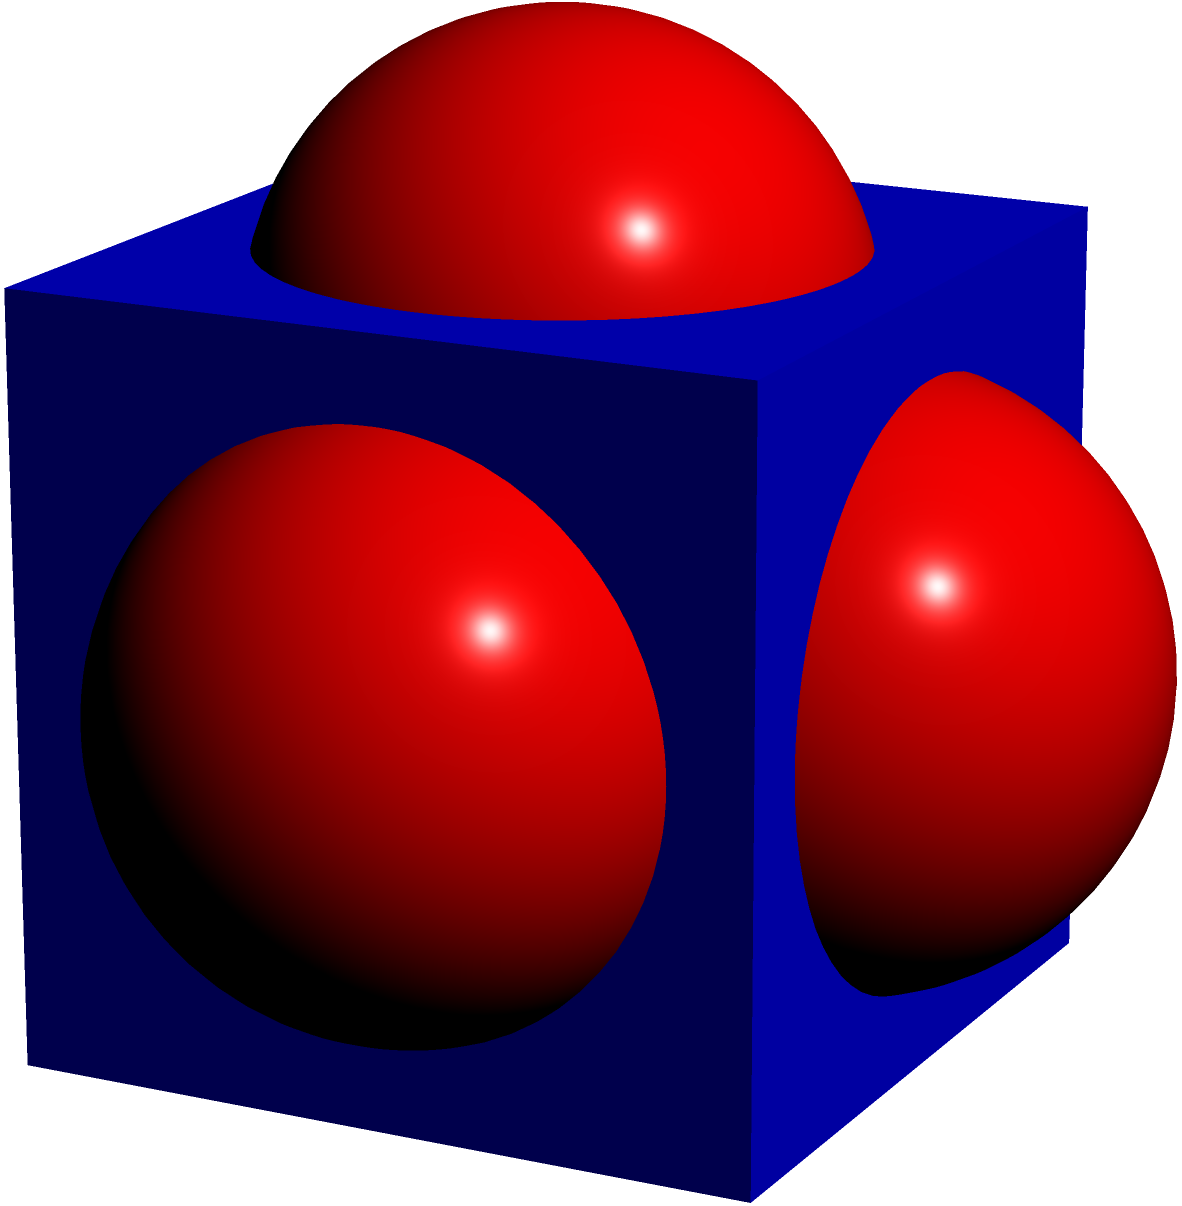As a fruit packer in your new job, you're tasked with efficiently packing spherical fruits into cubic crates. If the length of each side of the cubic crate is 10 inches and the diameter of each spherical fruit is 4 inches, how many fruits can you fit into one crate? To solve this problem, we'll follow these steps:

1) First, we need to determine how many fruits can fit along each dimension of the crate:
   - Length of crate side: 10 inches
   - Diameter of fruit: 4 inches
   - Number of fruits per side = $\lfloor \frac{10}{4} \rfloor = 2$ (we use the floor function as we can't have partial fruits)

2) Since the crate is cubic, this number applies to all three dimensions (length, width, height).

3) The total number of fruits that can fit is the product of the number of fruits in each dimension:
   $2 \times 2 \times 2 = 8$

4) However, this calculation assumes perfect packing, which isn't always possible with spheres. In reality, there might be some small spaces between the fruits, but for this idealized scenario, we'll assume perfect packing.

5) Therefore, the maximum number of spherical fruits that can fit into the cubic crate is 8.

This packing method is similar to how oranges or apples might be packed in boxes for shipping, which is a common task in fruit packing and distribution jobs.
Answer: 8 fruits 